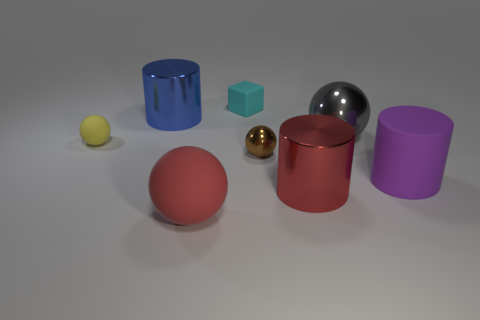How many other things are there of the same color as the big matte ball?
Provide a short and direct response. 1. The small cube behind the yellow matte object that is behind the brown sphere is made of what material?
Your answer should be very brief. Rubber. Does the metal cylinder behind the red shiny object have the same color as the tiny rubber block?
Ensure brevity in your answer.  No. What number of gray shiny balls are the same size as the blue metal cylinder?
Make the answer very short. 1. The big purple rubber object has what shape?
Offer a terse response. Cylinder. Is there a large cylinder of the same color as the large matte sphere?
Your answer should be compact. Yes. Is the number of rubber cylinders that are in front of the large blue metallic cylinder greater than the number of cyan rubber balls?
Offer a very short reply. Yes. There is a large red metal thing; does it have the same shape as the purple object in front of the yellow matte ball?
Your answer should be compact. Yes. Are any large purple objects visible?
Your response must be concise. Yes. How many tiny things are yellow spheres or gray matte objects?
Your answer should be compact. 1. 